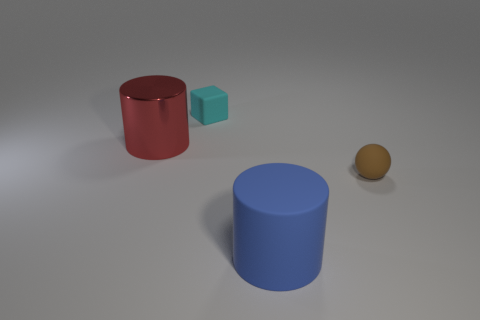Subtract 0 blue balls. How many objects are left? 4 Subtract all cubes. How many objects are left? 3 Subtract all green spheres. Subtract all brown cylinders. How many spheres are left? 1 Subtract all green cylinders. How many blue cubes are left? 0 Subtract all big red metallic cylinders. Subtract all rubber objects. How many objects are left? 0 Add 4 tiny cyan blocks. How many tiny cyan blocks are left? 5 Add 3 yellow rubber cylinders. How many yellow rubber cylinders exist? 3 Add 3 tiny cyan things. How many objects exist? 7 Subtract all red cylinders. How many cylinders are left? 1 